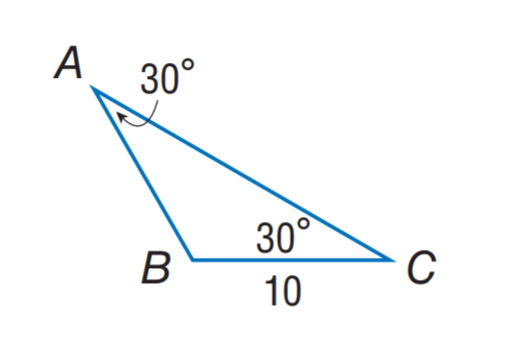Question: Find A B.
Choices:
A. 5
B. 10
C. 20
D. 30
Answer with the letter. Answer: B 